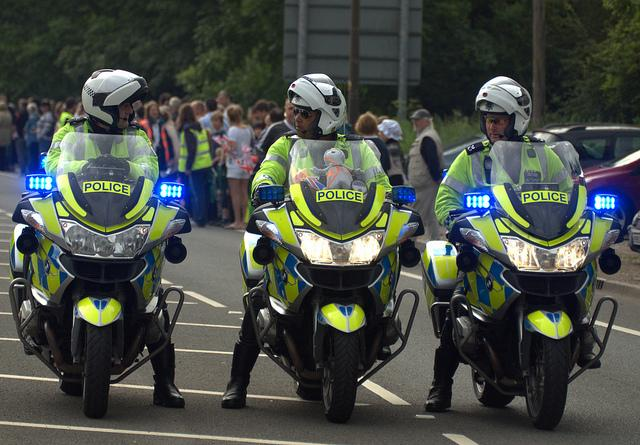Why are the bike riders wearing yellow?

Choices:
A) as prank
B) style
C) visibility
D) camouflage visibility 